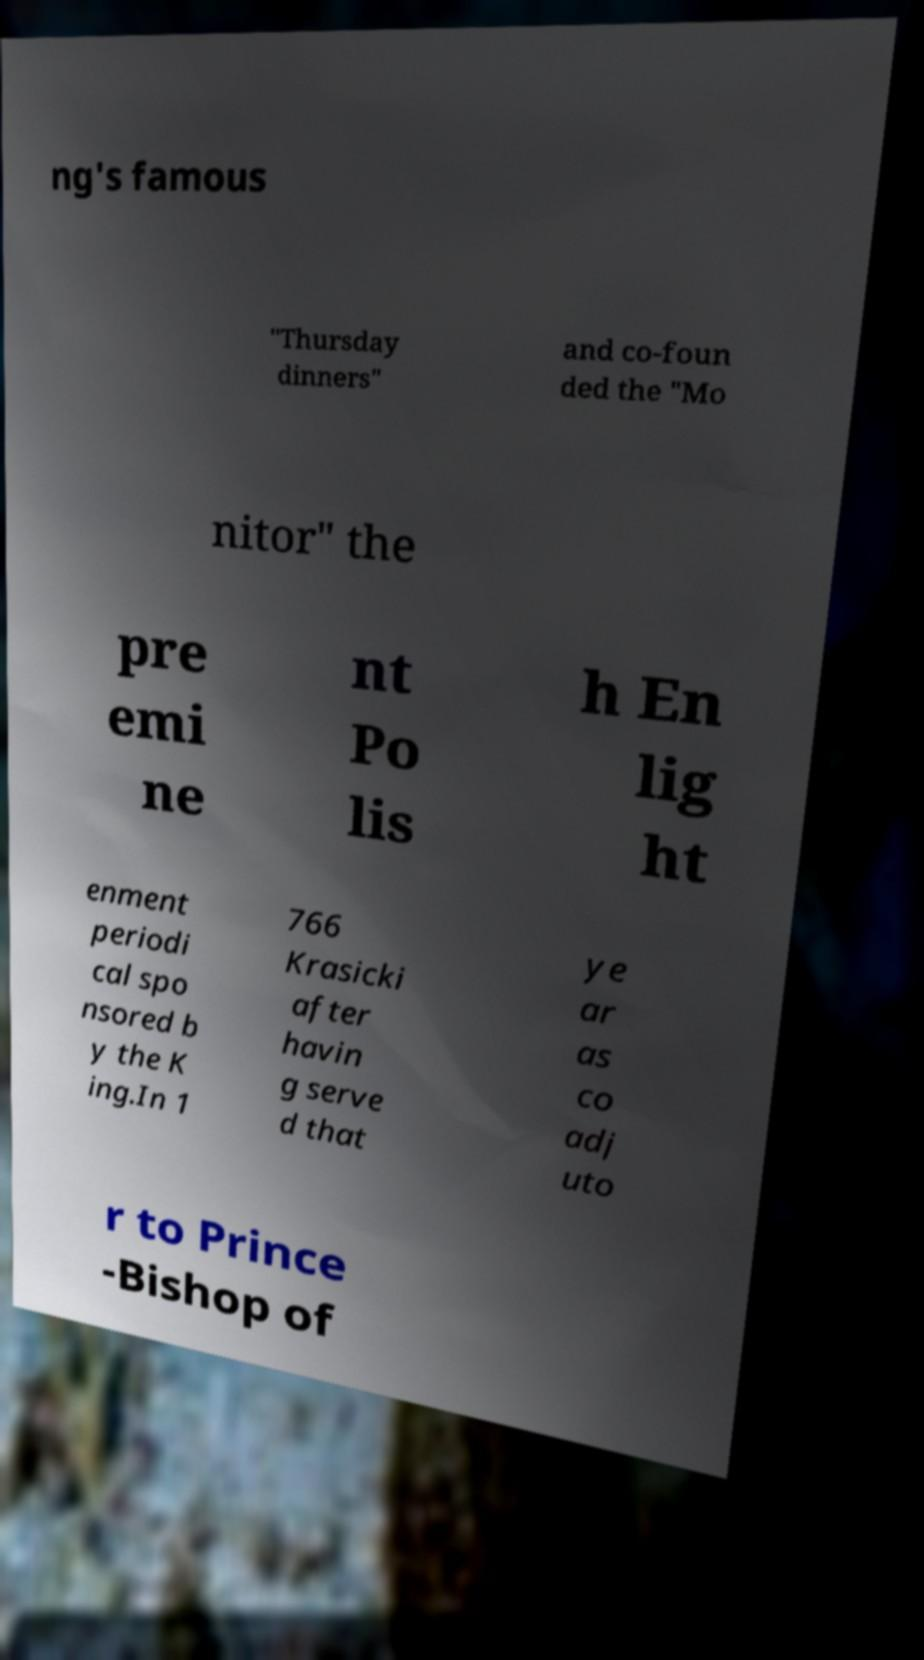Could you assist in decoding the text presented in this image and type it out clearly? ng's famous "Thursday dinners" and co-foun ded the "Mo nitor" the pre emi ne nt Po lis h En lig ht enment periodi cal spo nsored b y the K ing.In 1 766 Krasicki after havin g serve d that ye ar as co adj uto r to Prince -Bishop of 